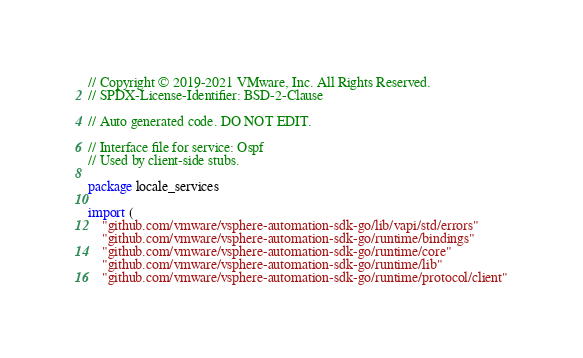Convert code to text. <code><loc_0><loc_0><loc_500><loc_500><_Go_>// Copyright © 2019-2021 VMware, Inc. All Rights Reserved.
// SPDX-License-Identifier: BSD-2-Clause

// Auto generated code. DO NOT EDIT.

// Interface file for service: Ospf
// Used by client-side stubs.

package locale_services

import (
	"github.com/vmware/vsphere-automation-sdk-go/lib/vapi/std/errors"
	"github.com/vmware/vsphere-automation-sdk-go/runtime/bindings"
	"github.com/vmware/vsphere-automation-sdk-go/runtime/core"
	"github.com/vmware/vsphere-automation-sdk-go/runtime/lib"
	"github.com/vmware/vsphere-automation-sdk-go/runtime/protocol/client"</code> 